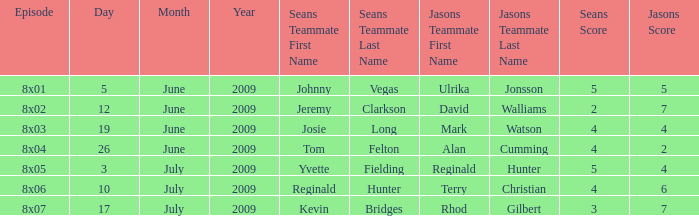Who was on Jason's team for the 12 June 2009 episode? David Walliams and Holly Walsh. 